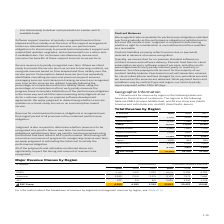According to Sap Ag's financial document, What is the amount for EMEA in 2019? According to the financial document, 12,105 (in millions). The relevant text states: "EMEA 12,105 11,104 10,415..." Also, What is the amount for APJ in 2018? According to the financial document, 3,891 (in millions). The relevant text states: "APJ 4,254 3,891 3,699..." Also, What are the broad categories making up the total revenue by region? The document contains multiple relevant values: EMEA, Americas, APJ. From the document: "Rest of Americas 2,109 1,832 1,911 Rest of APJ 3,074 2,928 2,814 Rest of EMEA 8,158 7,446 7,063..." Additionally, In which year was the amount for Germany the largest? According to the financial document, 2019. The relevant text states: "€ millions 2019 2018 2017..." Also, can you calculate: What was the change in APJ in 2019 from 2018? Based on the calculation: 4,254-3,891, the result is 363 (in millions). This is based on the information: "APJ 4,254 3,891 3,699 APJ 4,254 3,891 3,699..." The key data points involved are: 3,891, 4,254. Also, can you calculate: What was the percentage change in APJ in 2019 from 2018? To answer this question, I need to perform calculations using the financial data. The calculation is: (4,254-3,891)/3,891, which equals 9.33 (percentage). This is based on the information: "APJ 4,254 3,891 3,699 APJ 4,254 3,891 3,699..." The key data points involved are: 3,891, 4,254. 